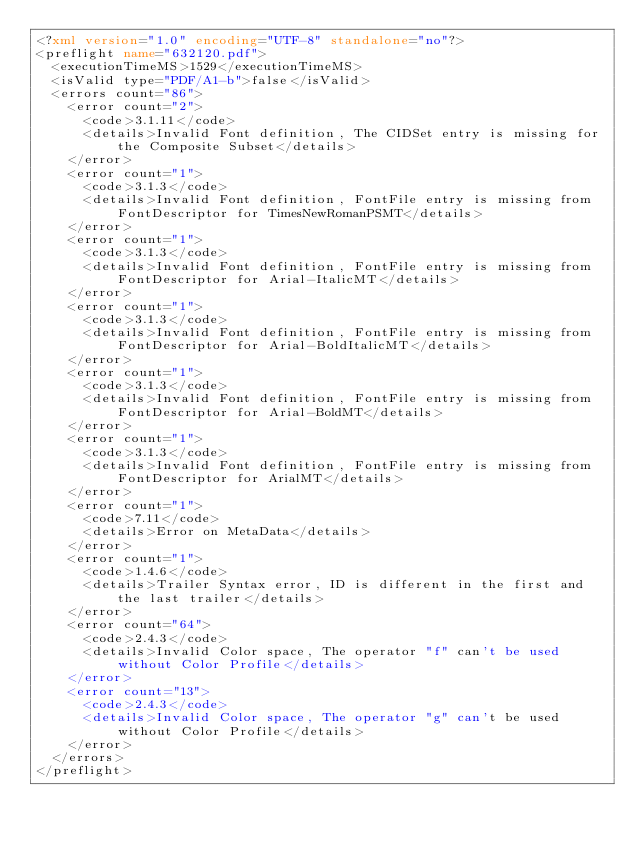Convert code to text. <code><loc_0><loc_0><loc_500><loc_500><_XML_><?xml version="1.0" encoding="UTF-8" standalone="no"?>
<preflight name="632120.pdf">
  <executionTimeMS>1529</executionTimeMS>
  <isValid type="PDF/A1-b">false</isValid>
  <errors count="86">
    <error count="2">
      <code>3.1.11</code>
      <details>Invalid Font definition, The CIDSet entry is missing for the Composite Subset</details>
    </error>
    <error count="1">
      <code>3.1.3</code>
      <details>Invalid Font definition, FontFile entry is missing from FontDescriptor for TimesNewRomanPSMT</details>
    </error>
    <error count="1">
      <code>3.1.3</code>
      <details>Invalid Font definition, FontFile entry is missing from FontDescriptor for Arial-ItalicMT</details>
    </error>
    <error count="1">
      <code>3.1.3</code>
      <details>Invalid Font definition, FontFile entry is missing from FontDescriptor for Arial-BoldItalicMT</details>
    </error>
    <error count="1">
      <code>3.1.3</code>
      <details>Invalid Font definition, FontFile entry is missing from FontDescriptor for Arial-BoldMT</details>
    </error>
    <error count="1">
      <code>3.1.3</code>
      <details>Invalid Font definition, FontFile entry is missing from FontDescriptor for ArialMT</details>
    </error>
    <error count="1">
      <code>7.11</code>
      <details>Error on MetaData</details>
    </error>
    <error count="1">
      <code>1.4.6</code>
      <details>Trailer Syntax error, ID is different in the first and the last trailer</details>
    </error>
    <error count="64">
      <code>2.4.3</code>
      <details>Invalid Color space, The operator "f" can't be used without Color Profile</details>
    </error>
    <error count="13">
      <code>2.4.3</code>
      <details>Invalid Color space, The operator "g" can't be used without Color Profile</details>
    </error>
  </errors>
</preflight>
</code> 